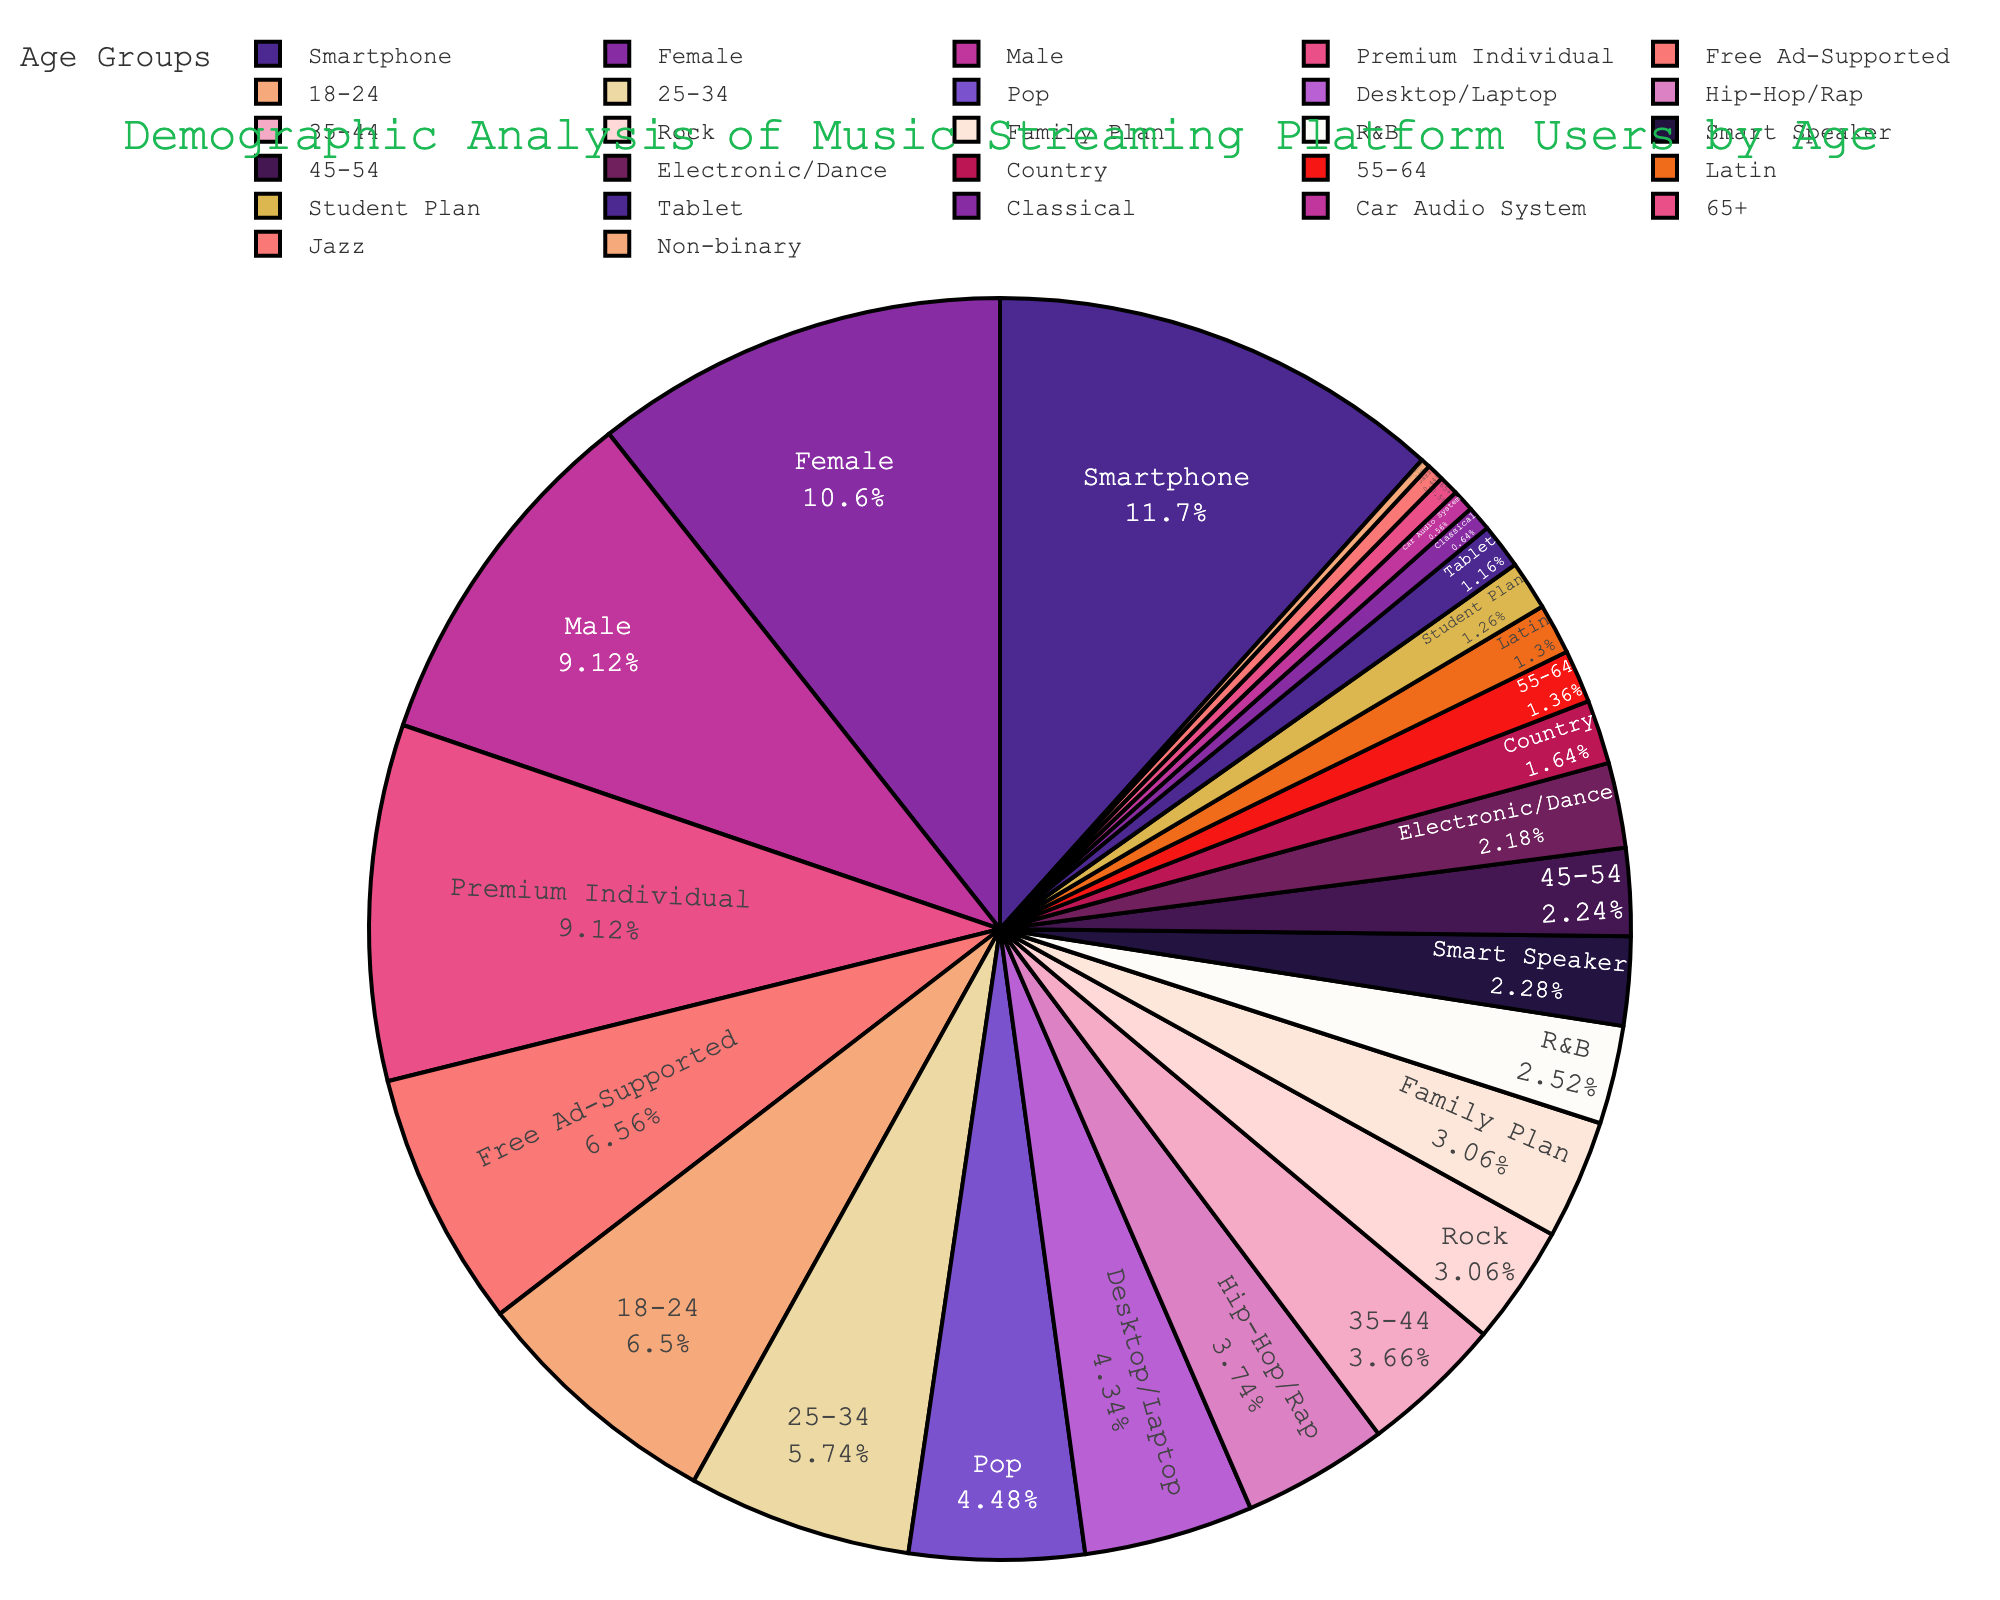What age group has the highest percentage of users on the music streaming platform? By looking at the pie chart, the segment with the largest area corresponds to the age group 18-24.
Answer: 18-24 Which age group has the lowest representation among users? The smallest slice in the pie chart represents the age group 65+, indicating it has the lowest percentage.
Answer: 65+ What is the combined percentage of users aged 25-34 and 35-44? The percentages for the age groups 25-34 and 35-44 are 28.7 and 18.3, respectively. Adding these together gives 28.7 + 18.3 = 47.0.
Answer: 47.0 What is the percentage difference between the 18-24 and 45-54 age groups? The percentage for 18-24 is 32.5, and for 45-54 it is 11.2. The difference is 32.5 - 11.2 = 21.3.
Answer: 21.3 Which age group is more represented on the platform, 35-44 or 45-54? Comparing the two segments, the slice for the 35-44 age group is larger than the one for 45-54.
Answer: 35-44 Do users aged 55-64 make up more or less than 10% of the total users? The pie chart shows that the segment for users aged 55-64 is 6.8%, which is less than 10%.
Answer: Less How does the sum of the percentages for users aged 45+ compare to the percentage of users aged 18-24? Sum the percentages for 45-54 (11.2), 55-64 (6.8), and 65+ (2.5) to get 11.2 + 6.8 + 2.5 = 20.5, which is less than the 32.5% for the 18-24 age group.
Answer: Less If we group users aged 18-34, what percentage of the total users do they represent? Combine the percentages for 18-24 (32.5) and 25-34 (28.7): 32.5 + 28.7 = 61.2.
Answer: 61.2 